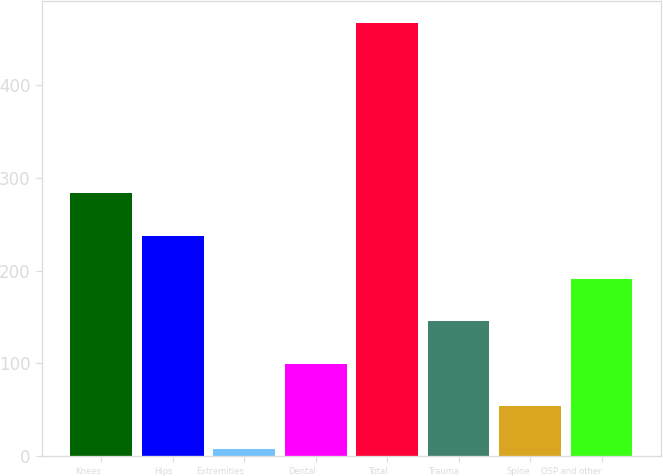Convert chart. <chart><loc_0><loc_0><loc_500><loc_500><bar_chart><fcel>Knees<fcel>Hips<fcel>Extremities<fcel>Dental<fcel>Total<fcel>Trauma<fcel>Spine<fcel>OSP and other<nl><fcel>283.4<fcel>237.35<fcel>7.1<fcel>99.2<fcel>467.6<fcel>145.25<fcel>53.15<fcel>191.3<nl></chart> 